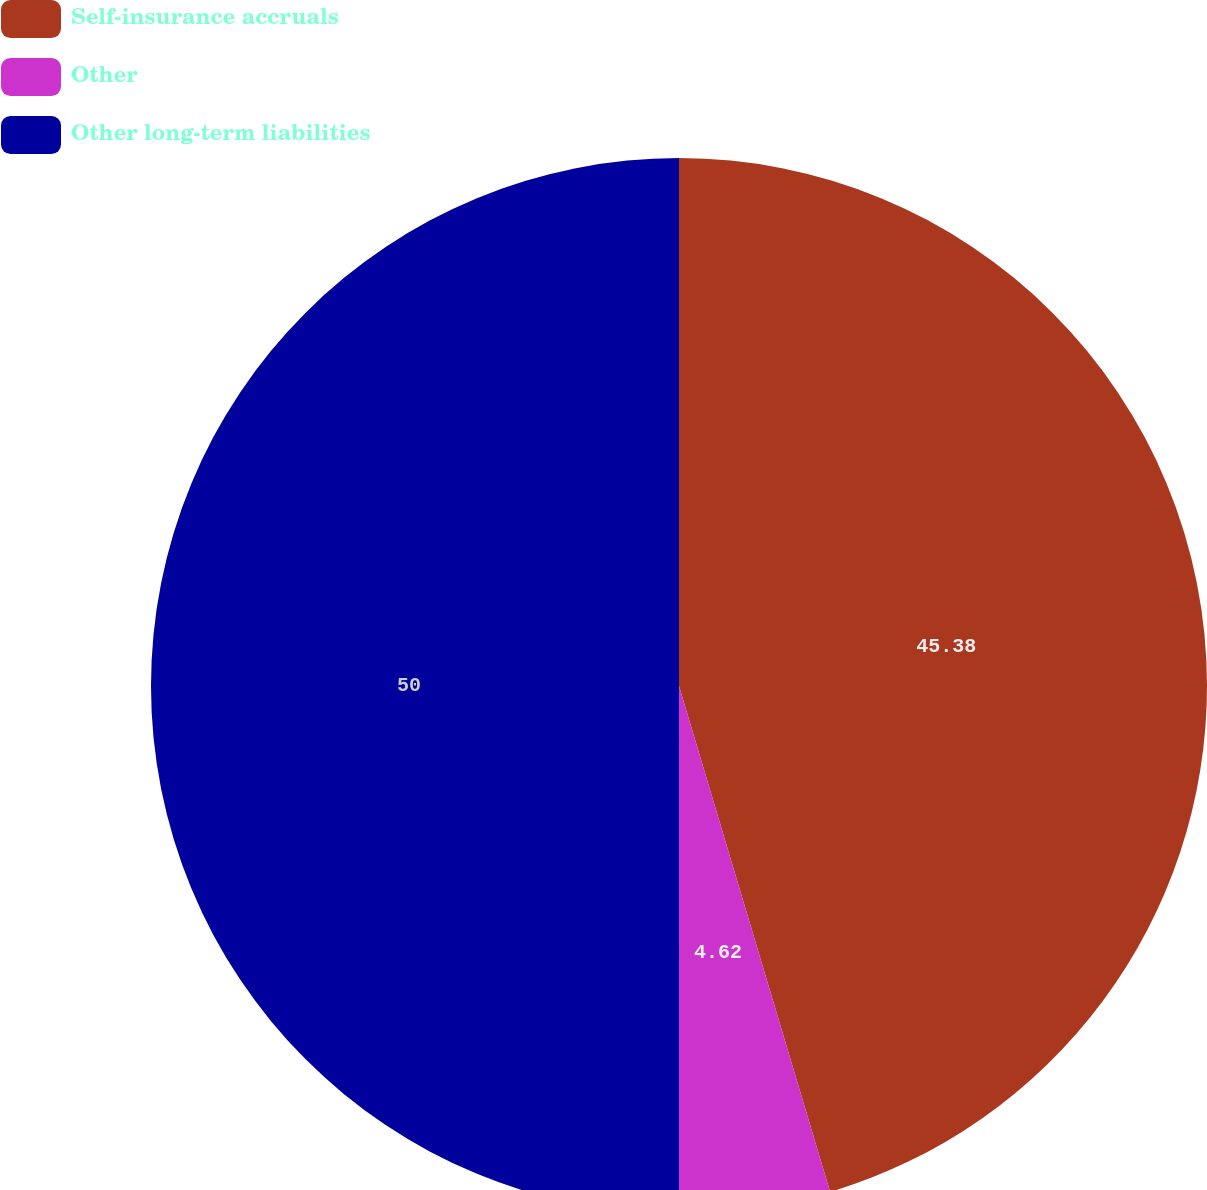Convert chart. <chart><loc_0><loc_0><loc_500><loc_500><pie_chart><fcel>Self-insurance accruals<fcel>Other<fcel>Other long-term liabilities<nl><fcel>45.38%<fcel>4.62%<fcel>50.0%<nl></chart> 